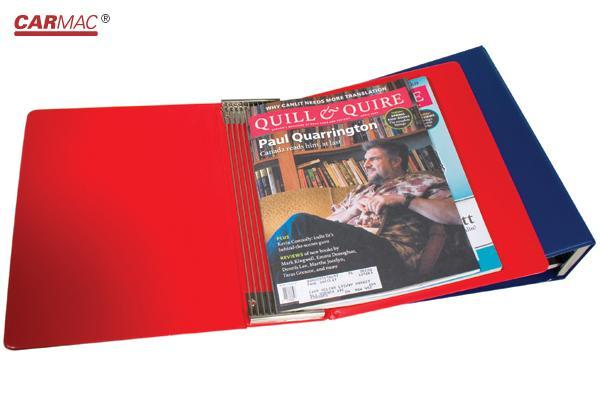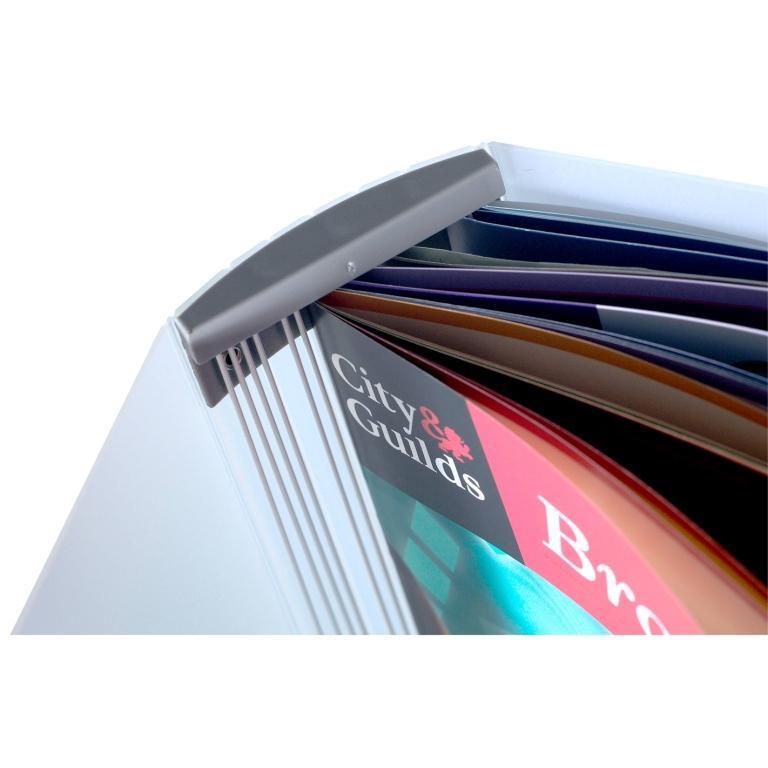The first image is the image on the left, the second image is the image on the right. For the images shown, is this caption "The left image includes a binder with a magazine featuring a woman on the cover." true? Answer yes or no. No. The first image is the image on the left, the second image is the image on the right. Given the left and right images, does the statement "There are two binders against a white background." hold true? Answer yes or no. Yes. 